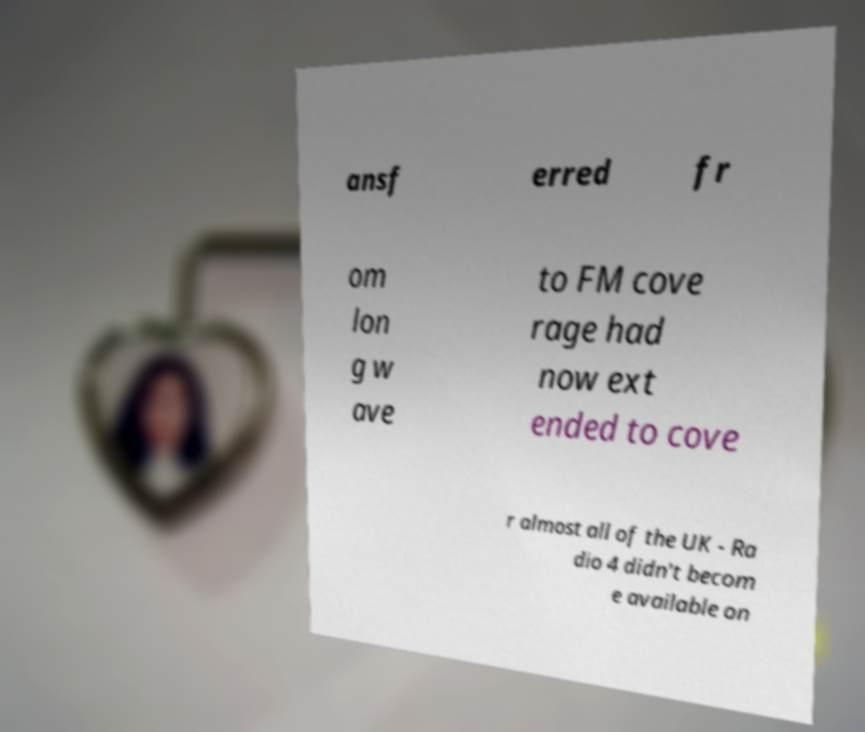Please identify and transcribe the text found in this image. ansf erred fr om lon g w ave to FM cove rage had now ext ended to cove r almost all of the UK - Ra dio 4 didn't becom e available on 